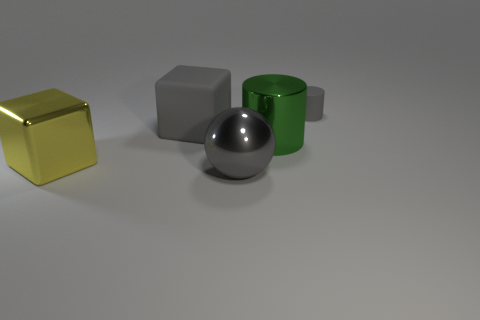Describe the atmosphere you feel looking at this image. The image conveys a calm and clean atmosphere, with a minimalist appeal due to the neutral background and the simple yet distinct shapes of the objects. It provides a sense of order and balance, with a touch of intrigue due to the shiny and matte surfaces interacting with light. 